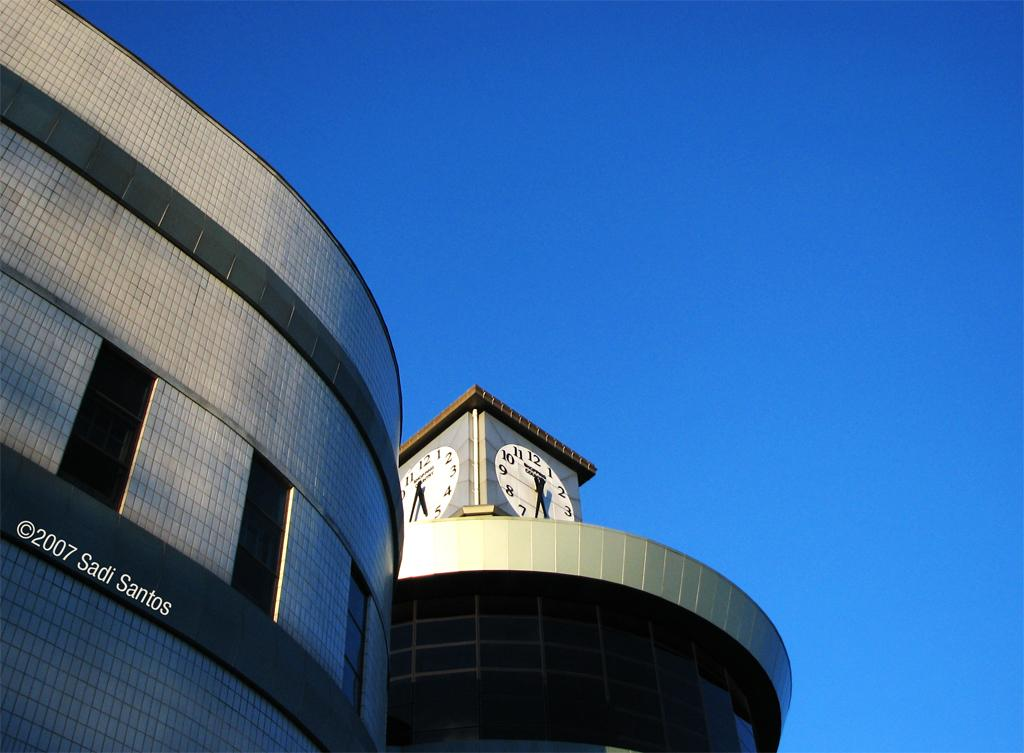What type of structures are present in the image? There are buildings with windows in the image. Can you describe any text or symbols on the buildings? Something is written on the building. What feature can be seen on top of the buildings? There are clocks on top of the building. What can be seen in the background of the image? The sky is visible in the background of the image. What type of attack is being carried out by the duck in the image? There is no duck present in the image, so no attack can be observed. 